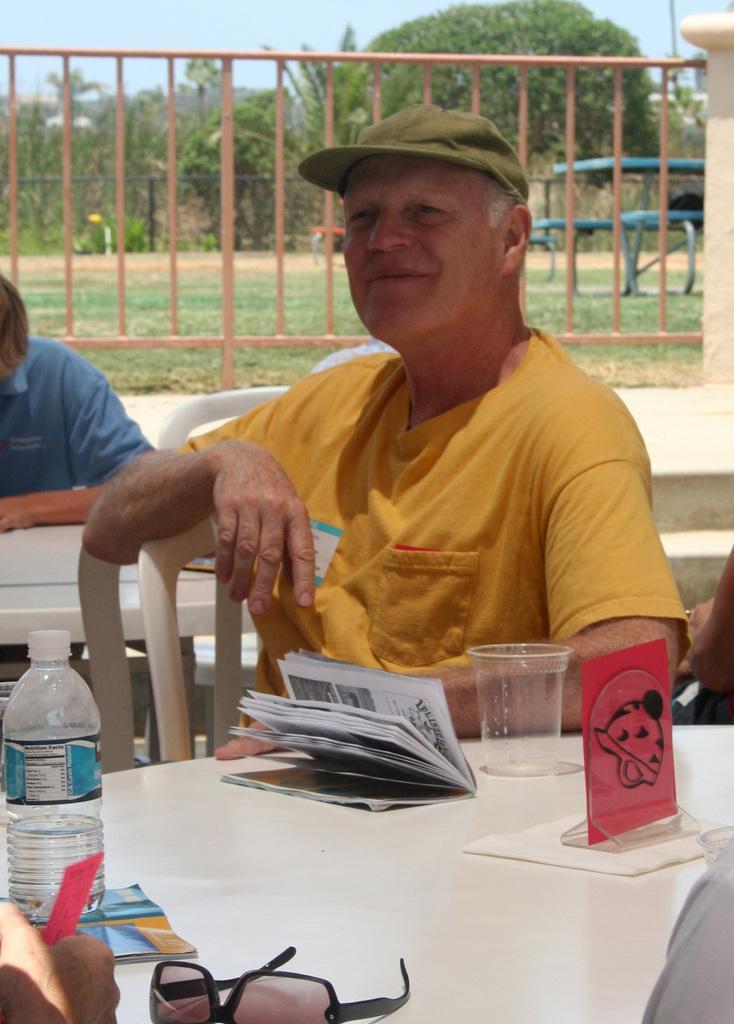Can you describe this image briefly? This is an outside view. Here can see a man sitting on the chair in front of the table. On the I can see a bottle, book, glass and goggles. On the left corner of the image I can see only a person's hand. In the background I can see the trees and the sky. This man is wearing yellow color t-shirt and cap on his head. 